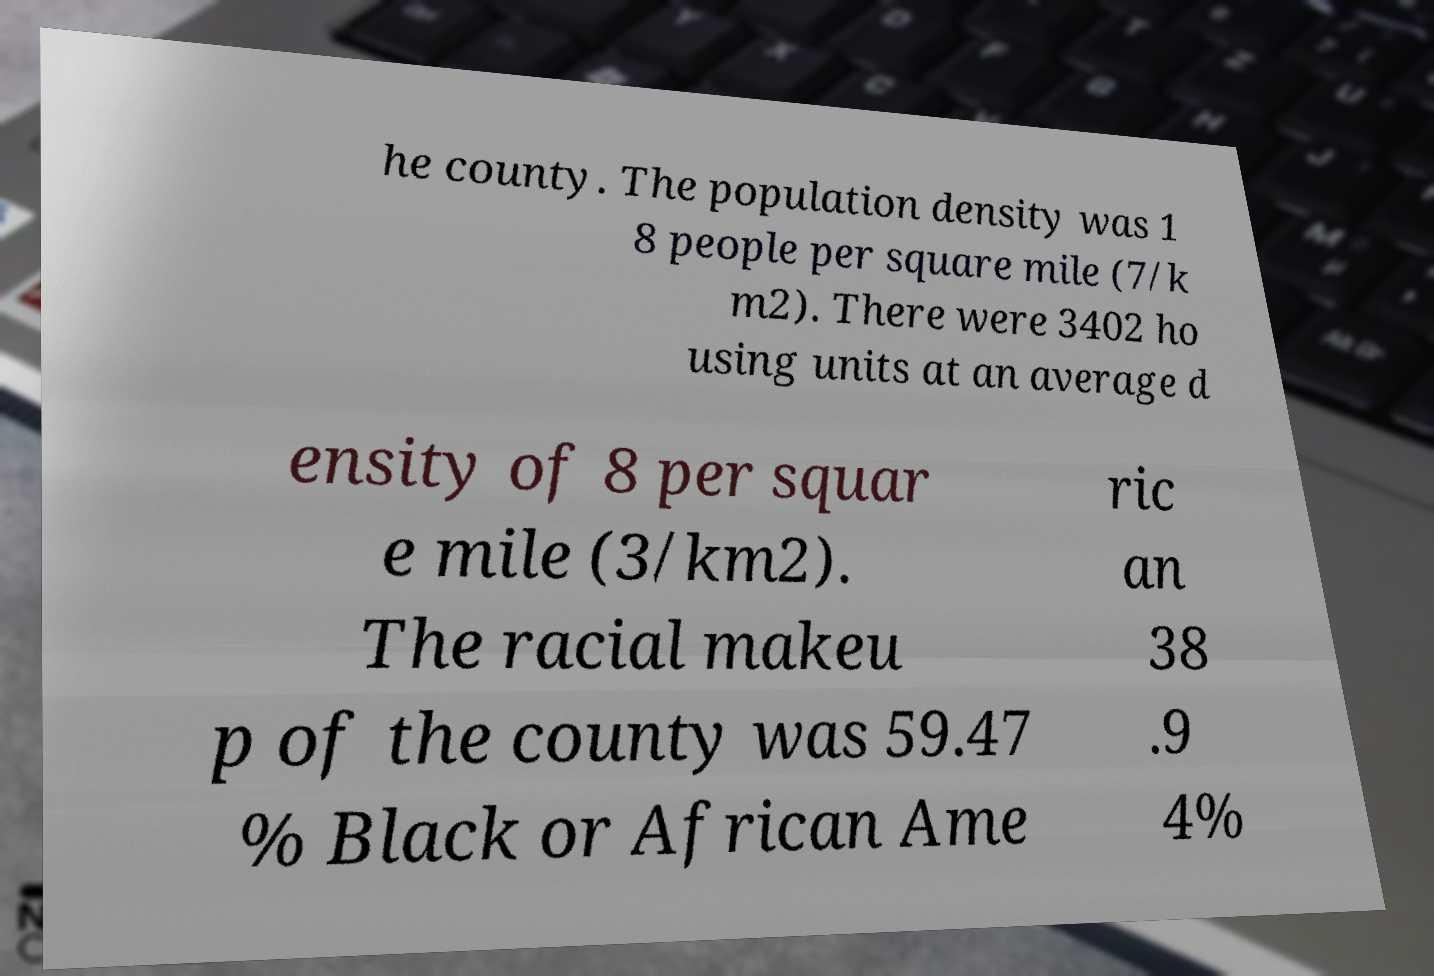Can you accurately transcribe the text from the provided image for me? he county. The population density was 1 8 people per square mile (7/k m2). There were 3402 ho using units at an average d ensity of 8 per squar e mile (3/km2). The racial makeu p of the county was 59.47 % Black or African Ame ric an 38 .9 4% 